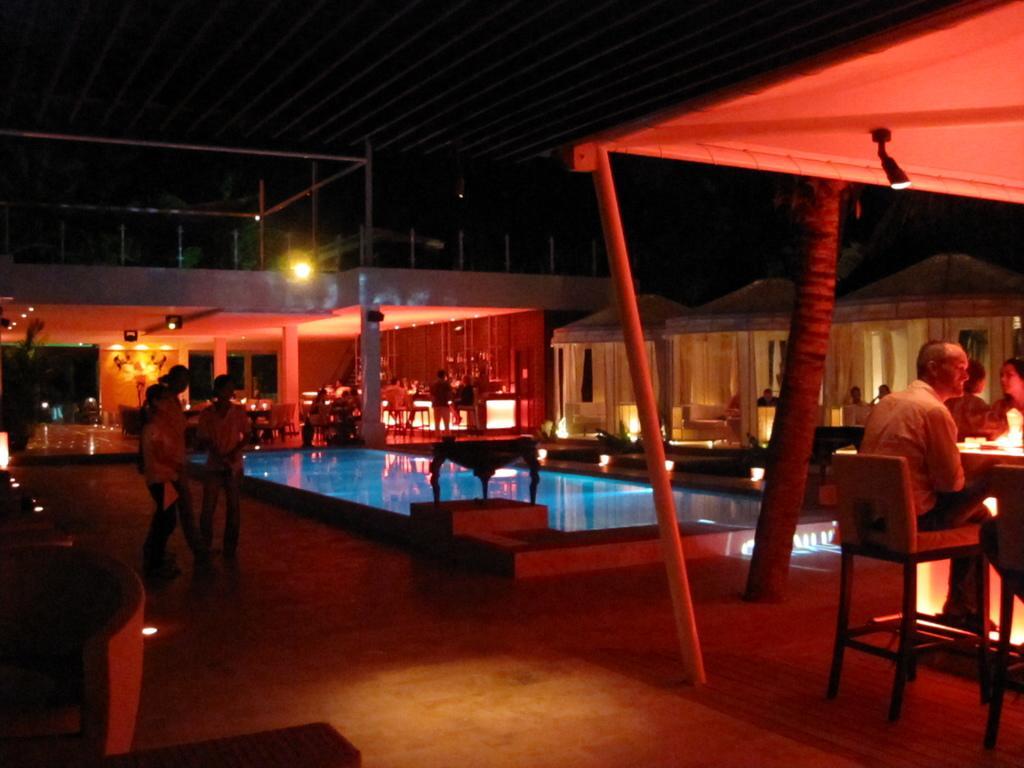Could you give a brief overview of what you see in this image? people are sitting on the chairs under the tents. behind them there is a pool and building. at the left people are standing and it's the nighttime. 